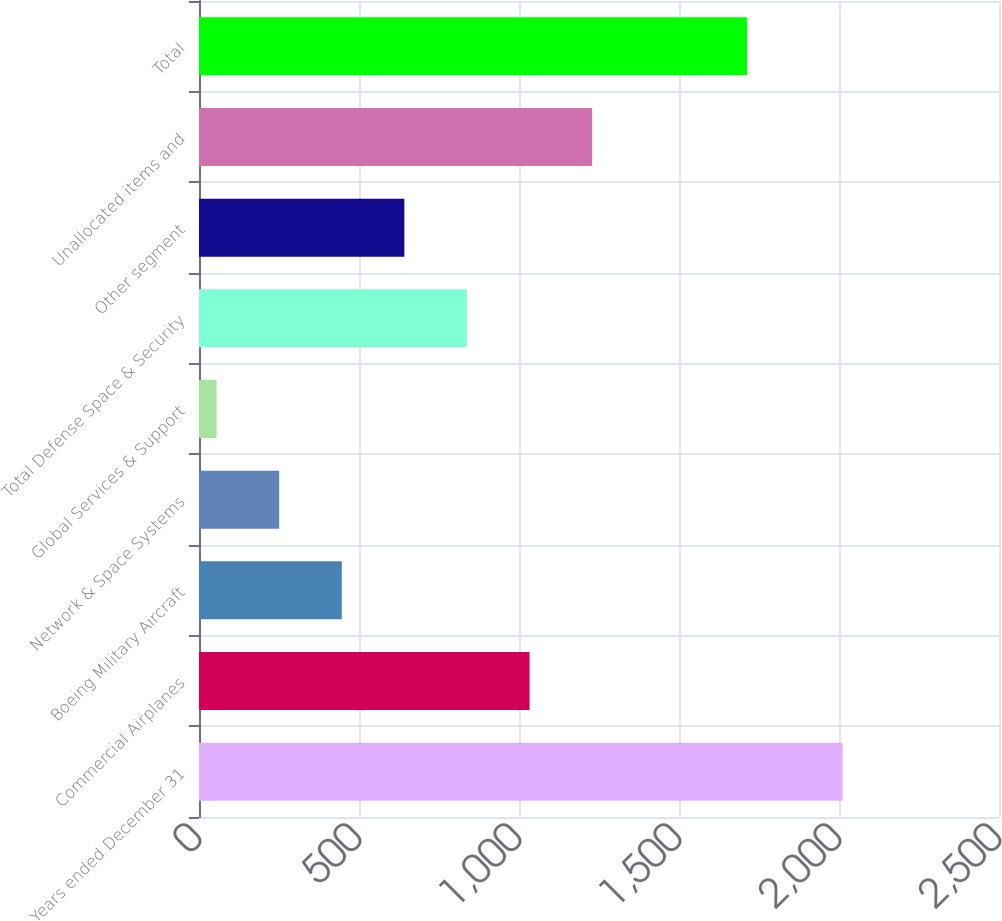<chart> <loc_0><loc_0><loc_500><loc_500><bar_chart><fcel>Years ended December 31<fcel>Commercial Airplanes<fcel>Boeing Military Aircraft<fcel>Network & Space Systems<fcel>Global Services & Support<fcel>Total Defense Space & Security<fcel>Other segment<fcel>Unallocated items and<fcel>Total<nl><fcel>2011<fcel>1033<fcel>446.2<fcel>250.6<fcel>55<fcel>837.4<fcel>641.8<fcel>1228.6<fcel>1713<nl></chart> 